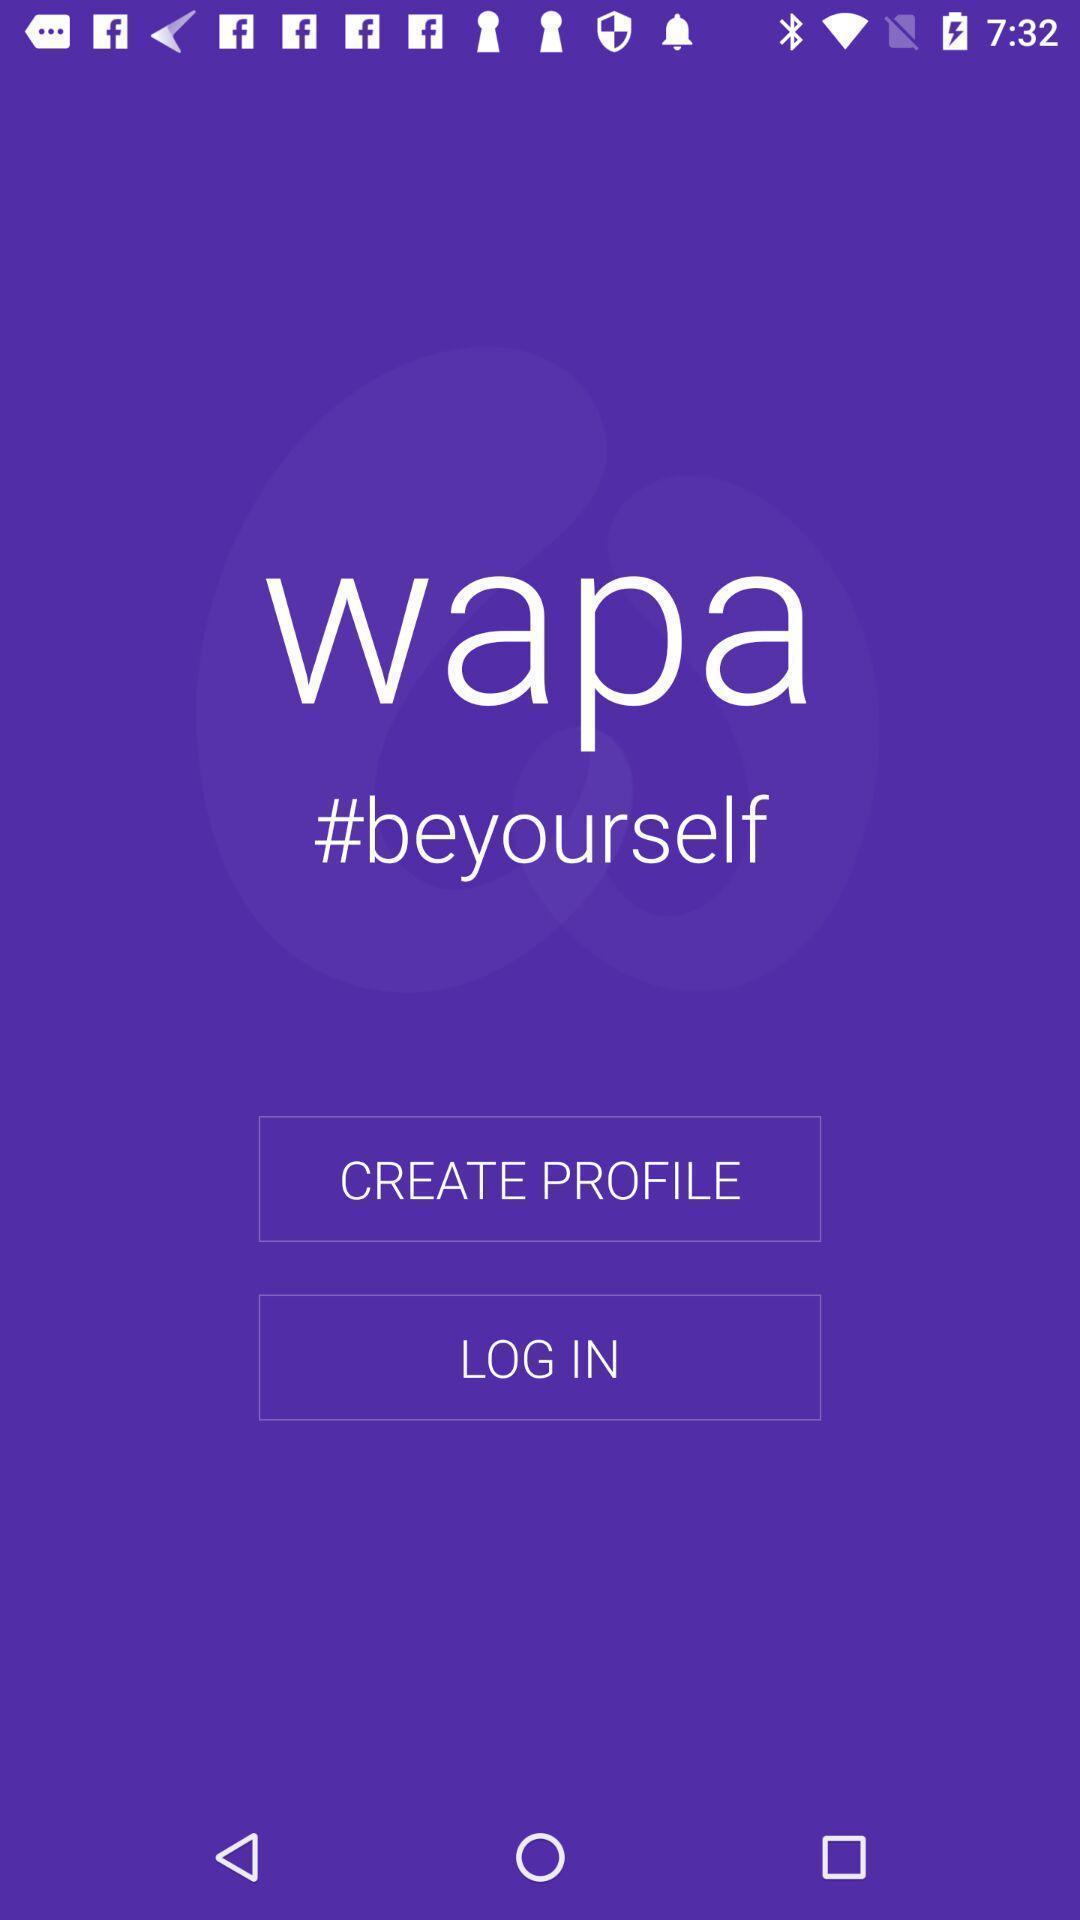Summarize the main components in this picture. Welcome to the login page. 